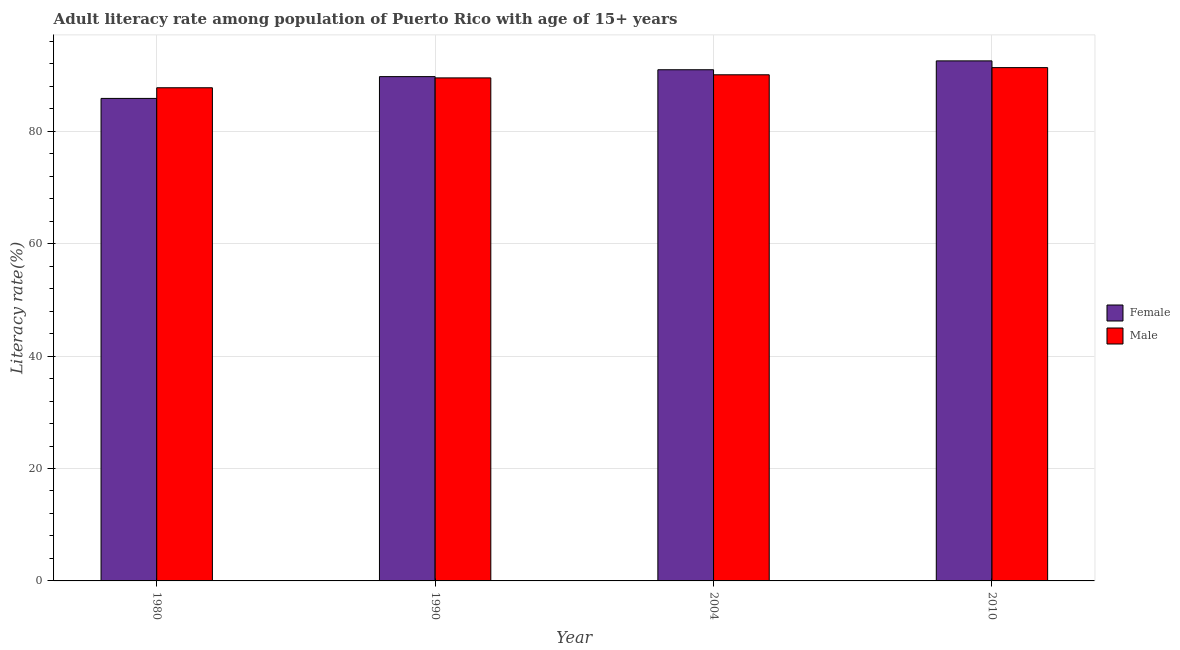How many different coloured bars are there?
Offer a very short reply. 2. How many groups of bars are there?
Provide a succinct answer. 4. Are the number of bars per tick equal to the number of legend labels?
Your answer should be compact. Yes. Are the number of bars on each tick of the X-axis equal?
Keep it short and to the point. Yes. What is the label of the 4th group of bars from the left?
Make the answer very short. 2010. In how many cases, is the number of bars for a given year not equal to the number of legend labels?
Keep it short and to the point. 0. What is the female adult literacy rate in 1990?
Offer a terse response. 89.73. Across all years, what is the maximum female adult literacy rate?
Ensure brevity in your answer.  92.53. Across all years, what is the minimum female adult literacy rate?
Keep it short and to the point. 85.85. In which year was the female adult literacy rate minimum?
Your answer should be very brief. 1980. What is the total female adult literacy rate in the graph?
Ensure brevity in your answer.  359.06. What is the difference between the female adult literacy rate in 1980 and that in 2004?
Your answer should be very brief. -5.1. What is the difference between the male adult literacy rate in 2010 and the female adult literacy rate in 2004?
Ensure brevity in your answer.  1.28. What is the average male adult literacy rate per year?
Your response must be concise. 89.66. In the year 2010, what is the difference between the male adult literacy rate and female adult literacy rate?
Provide a succinct answer. 0. What is the ratio of the male adult literacy rate in 1990 to that in 2004?
Give a very brief answer. 0.99. Is the difference between the female adult literacy rate in 1980 and 2004 greater than the difference between the male adult literacy rate in 1980 and 2004?
Keep it short and to the point. No. What is the difference between the highest and the second highest female adult literacy rate?
Keep it short and to the point. 1.58. What is the difference between the highest and the lowest male adult literacy rate?
Your response must be concise. 3.58. What does the 2nd bar from the left in 2004 represents?
Ensure brevity in your answer.  Male. How many bars are there?
Give a very brief answer. 8. Are the values on the major ticks of Y-axis written in scientific E-notation?
Give a very brief answer. No. Does the graph contain any zero values?
Ensure brevity in your answer.  No. Where does the legend appear in the graph?
Offer a very short reply. Center right. How are the legend labels stacked?
Ensure brevity in your answer.  Vertical. What is the title of the graph?
Keep it short and to the point. Adult literacy rate among population of Puerto Rico with age of 15+ years. Does "Working capital" appear as one of the legend labels in the graph?
Your answer should be very brief. No. What is the label or title of the Y-axis?
Provide a succinct answer. Literacy rate(%). What is the Literacy rate(%) in Female in 1980?
Provide a succinct answer. 85.85. What is the Literacy rate(%) of Male in 1980?
Your answer should be compact. 87.75. What is the Literacy rate(%) in Female in 1990?
Make the answer very short. 89.73. What is the Literacy rate(%) of Male in 1990?
Your response must be concise. 89.5. What is the Literacy rate(%) of Female in 2004?
Keep it short and to the point. 90.95. What is the Literacy rate(%) in Male in 2004?
Offer a terse response. 90.05. What is the Literacy rate(%) of Female in 2010?
Offer a terse response. 92.53. What is the Literacy rate(%) of Male in 2010?
Offer a terse response. 91.33. Across all years, what is the maximum Literacy rate(%) in Female?
Offer a terse response. 92.53. Across all years, what is the maximum Literacy rate(%) of Male?
Your answer should be compact. 91.33. Across all years, what is the minimum Literacy rate(%) of Female?
Provide a succinct answer. 85.85. Across all years, what is the minimum Literacy rate(%) in Male?
Provide a short and direct response. 87.75. What is the total Literacy rate(%) of Female in the graph?
Keep it short and to the point. 359.06. What is the total Literacy rate(%) in Male in the graph?
Offer a very short reply. 358.64. What is the difference between the Literacy rate(%) of Female in 1980 and that in 1990?
Your answer should be very brief. -3.88. What is the difference between the Literacy rate(%) in Male in 1980 and that in 1990?
Make the answer very short. -1.75. What is the difference between the Literacy rate(%) in Female in 1980 and that in 2004?
Provide a succinct answer. -5.1. What is the difference between the Literacy rate(%) of Male in 1980 and that in 2004?
Make the answer very short. -2.31. What is the difference between the Literacy rate(%) in Female in 1980 and that in 2010?
Your response must be concise. -6.68. What is the difference between the Literacy rate(%) of Male in 1980 and that in 2010?
Keep it short and to the point. -3.58. What is the difference between the Literacy rate(%) of Female in 1990 and that in 2004?
Your answer should be very brief. -1.22. What is the difference between the Literacy rate(%) in Male in 1990 and that in 2004?
Ensure brevity in your answer.  -0.55. What is the difference between the Literacy rate(%) in Female in 1990 and that in 2010?
Keep it short and to the point. -2.8. What is the difference between the Literacy rate(%) of Male in 1990 and that in 2010?
Your answer should be very brief. -1.83. What is the difference between the Literacy rate(%) of Female in 2004 and that in 2010?
Your answer should be compact. -1.58. What is the difference between the Literacy rate(%) in Male in 2004 and that in 2010?
Your answer should be compact. -1.28. What is the difference between the Literacy rate(%) in Female in 1980 and the Literacy rate(%) in Male in 1990?
Offer a terse response. -3.65. What is the difference between the Literacy rate(%) in Female in 1980 and the Literacy rate(%) in Male in 2004?
Provide a succinct answer. -4.2. What is the difference between the Literacy rate(%) in Female in 1980 and the Literacy rate(%) in Male in 2010?
Offer a very short reply. -5.48. What is the difference between the Literacy rate(%) in Female in 1990 and the Literacy rate(%) in Male in 2004?
Provide a short and direct response. -0.32. What is the difference between the Literacy rate(%) of Female in 1990 and the Literacy rate(%) of Male in 2010?
Provide a succinct answer. -1.6. What is the difference between the Literacy rate(%) in Female in 2004 and the Literacy rate(%) in Male in 2010?
Make the answer very short. -0.38. What is the average Literacy rate(%) of Female per year?
Your response must be concise. 89.77. What is the average Literacy rate(%) in Male per year?
Make the answer very short. 89.66. In the year 1980, what is the difference between the Literacy rate(%) of Female and Literacy rate(%) of Male?
Offer a terse response. -1.9. In the year 1990, what is the difference between the Literacy rate(%) in Female and Literacy rate(%) in Male?
Give a very brief answer. 0.23. In the year 2004, what is the difference between the Literacy rate(%) in Female and Literacy rate(%) in Male?
Make the answer very short. 0.9. In the year 2010, what is the difference between the Literacy rate(%) of Female and Literacy rate(%) of Male?
Ensure brevity in your answer.  1.2. What is the ratio of the Literacy rate(%) of Female in 1980 to that in 1990?
Provide a succinct answer. 0.96. What is the ratio of the Literacy rate(%) in Male in 1980 to that in 1990?
Offer a very short reply. 0.98. What is the ratio of the Literacy rate(%) in Female in 1980 to that in 2004?
Keep it short and to the point. 0.94. What is the ratio of the Literacy rate(%) of Male in 1980 to that in 2004?
Your response must be concise. 0.97. What is the ratio of the Literacy rate(%) of Female in 1980 to that in 2010?
Offer a very short reply. 0.93. What is the ratio of the Literacy rate(%) in Male in 1980 to that in 2010?
Provide a short and direct response. 0.96. What is the ratio of the Literacy rate(%) in Female in 1990 to that in 2004?
Your response must be concise. 0.99. What is the ratio of the Literacy rate(%) in Male in 1990 to that in 2004?
Make the answer very short. 0.99. What is the ratio of the Literacy rate(%) of Female in 1990 to that in 2010?
Your response must be concise. 0.97. What is the ratio of the Literacy rate(%) in Male in 1990 to that in 2010?
Offer a terse response. 0.98. What is the ratio of the Literacy rate(%) in Female in 2004 to that in 2010?
Keep it short and to the point. 0.98. What is the ratio of the Literacy rate(%) of Male in 2004 to that in 2010?
Offer a terse response. 0.99. What is the difference between the highest and the second highest Literacy rate(%) in Female?
Your response must be concise. 1.58. What is the difference between the highest and the second highest Literacy rate(%) of Male?
Provide a succinct answer. 1.28. What is the difference between the highest and the lowest Literacy rate(%) of Female?
Your answer should be compact. 6.68. What is the difference between the highest and the lowest Literacy rate(%) in Male?
Your answer should be very brief. 3.58. 